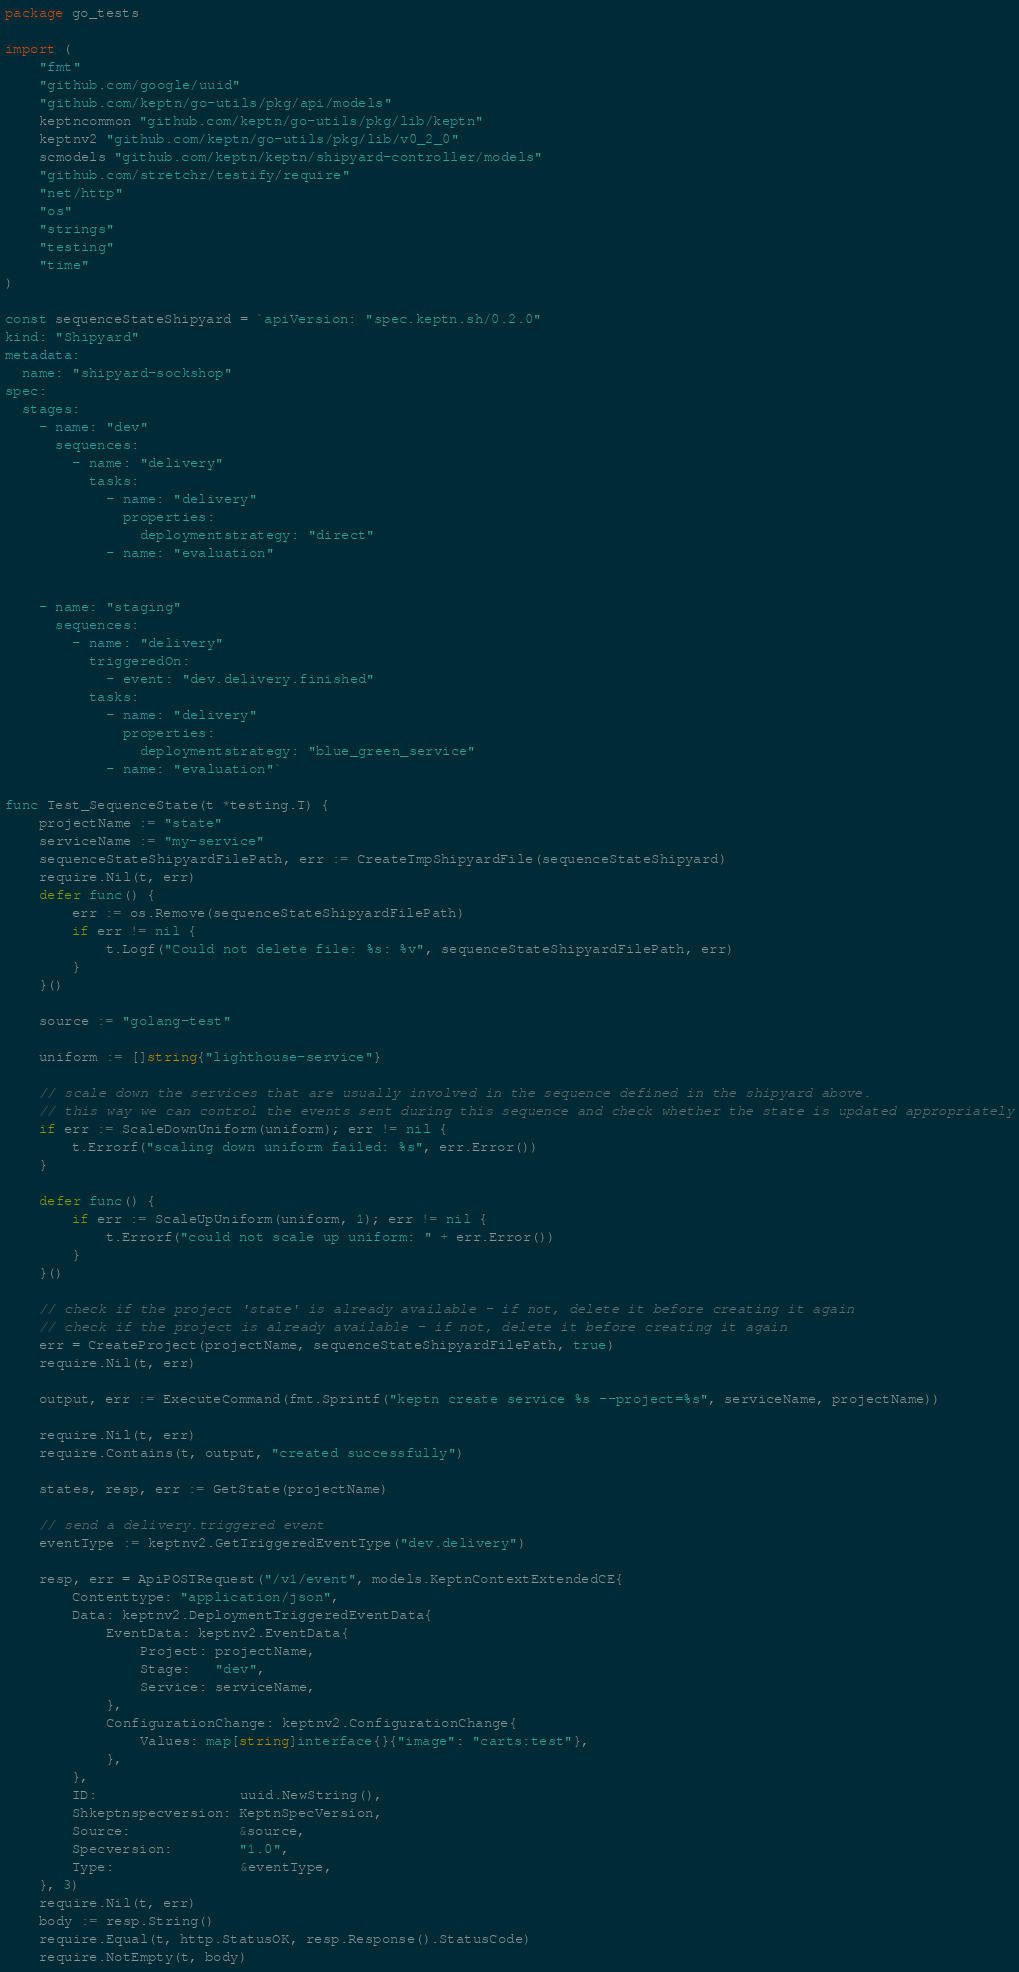<code> <loc_0><loc_0><loc_500><loc_500><_Go_>package go_tests

import (
	"fmt"
	"github.com/google/uuid"
	"github.com/keptn/go-utils/pkg/api/models"
	keptncommon "github.com/keptn/go-utils/pkg/lib/keptn"
	keptnv2 "github.com/keptn/go-utils/pkg/lib/v0_2_0"
	scmodels "github.com/keptn/keptn/shipyard-controller/models"
	"github.com/stretchr/testify/require"
	"net/http"
	"os"
	"strings"
	"testing"
	"time"
)

const sequenceStateShipyard = `apiVersion: "spec.keptn.sh/0.2.0"
kind: "Shipyard"
metadata:
  name: "shipyard-sockshop"
spec:
  stages:
    - name: "dev"
      sequences:
        - name: "delivery"
          tasks:
            - name: "delivery"
              properties:
                deploymentstrategy: "direct"
            - name: "evaluation"


    - name: "staging"
      sequences:
        - name: "delivery"
          triggeredOn:
            - event: "dev.delivery.finished"
          tasks:
            - name: "delivery"
              properties:
                deploymentstrategy: "blue_green_service"
            - name: "evaluation"`

func Test_SequenceState(t *testing.T) {
	projectName := "state"
	serviceName := "my-service"
	sequenceStateShipyardFilePath, err := CreateTmpShipyardFile(sequenceStateShipyard)
	require.Nil(t, err)
	defer func() {
		err := os.Remove(sequenceStateShipyardFilePath)
		if err != nil {
			t.Logf("Could not delete file: %s: %v", sequenceStateShipyardFilePath, err)
		}
	}()

	source := "golang-test"

	uniform := []string{"lighthouse-service"}

	// scale down the services that are usually involved in the sequence defined in the shipyard above.
	// this way we can control the events sent during this sequence and check whether the state is updated appropriately
	if err := ScaleDownUniform(uniform); err != nil {
		t.Errorf("scaling down uniform failed: %s", err.Error())
	}

	defer func() {
		if err := ScaleUpUniform(uniform, 1); err != nil {
			t.Errorf("could not scale up uniform: " + err.Error())
		}
	}()

	// check if the project 'state' is already available - if not, delete it before creating it again
	// check if the project is already available - if not, delete it before creating it again
	err = CreateProject(projectName, sequenceStateShipyardFilePath, true)
	require.Nil(t, err)

	output, err := ExecuteCommand(fmt.Sprintf("keptn create service %s --project=%s", serviceName, projectName))

	require.Nil(t, err)
	require.Contains(t, output, "created successfully")

	states, resp, err := GetState(projectName)

	// send a delivery.triggered event
	eventType := keptnv2.GetTriggeredEventType("dev.delivery")

	resp, err = ApiPOSTRequest("/v1/event", models.KeptnContextExtendedCE{
		Contenttype: "application/json",
		Data: keptnv2.DeploymentTriggeredEventData{
			EventData: keptnv2.EventData{
				Project: projectName,
				Stage:   "dev",
				Service: serviceName,
			},
			ConfigurationChange: keptnv2.ConfigurationChange{
				Values: map[string]interface{}{"image": "carts:test"},
			},
		},
		ID:                 uuid.NewString(),
		Shkeptnspecversion: KeptnSpecVersion,
		Source:             &source,
		Specversion:        "1.0",
		Type:               &eventType,
	}, 3)
	require.Nil(t, err)
	body := resp.String()
	require.Equal(t, http.StatusOK, resp.Response().StatusCode)
	require.NotEmpty(t, body)
</code> 